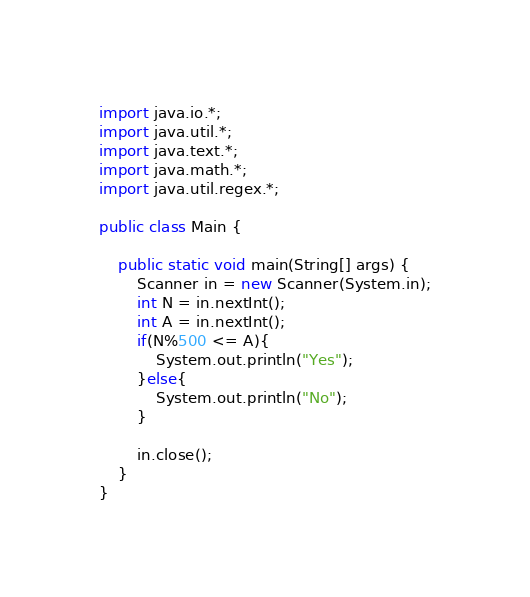<code> <loc_0><loc_0><loc_500><loc_500><_Java_>import java.io.*;
import java.util.*;
import java.text.*;
import java.math.*;
import java.util.regex.*;

public class Main {

    public static void main(String[] args) {
        Scanner in = new Scanner(System.in);
        int N = in.nextInt();
        int A = in.nextInt();
        if(N%500 <= A){
            System.out.println("Yes");
        }else{
            System.out.println("No");
        }

        in.close();
    }
}
</code> 